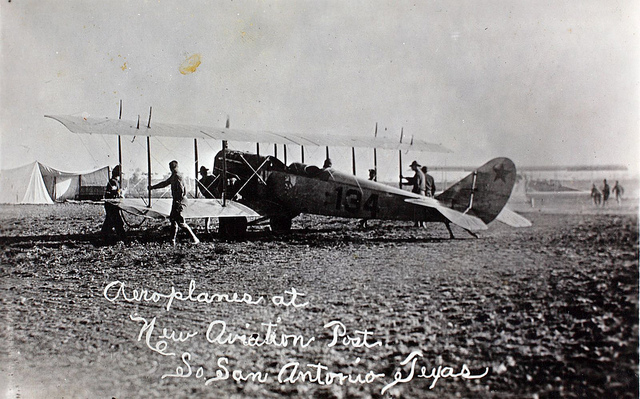Identify the text displayed in this image. 134 aeroplanes at new Quiatron Posts Jeyas antorio San So 